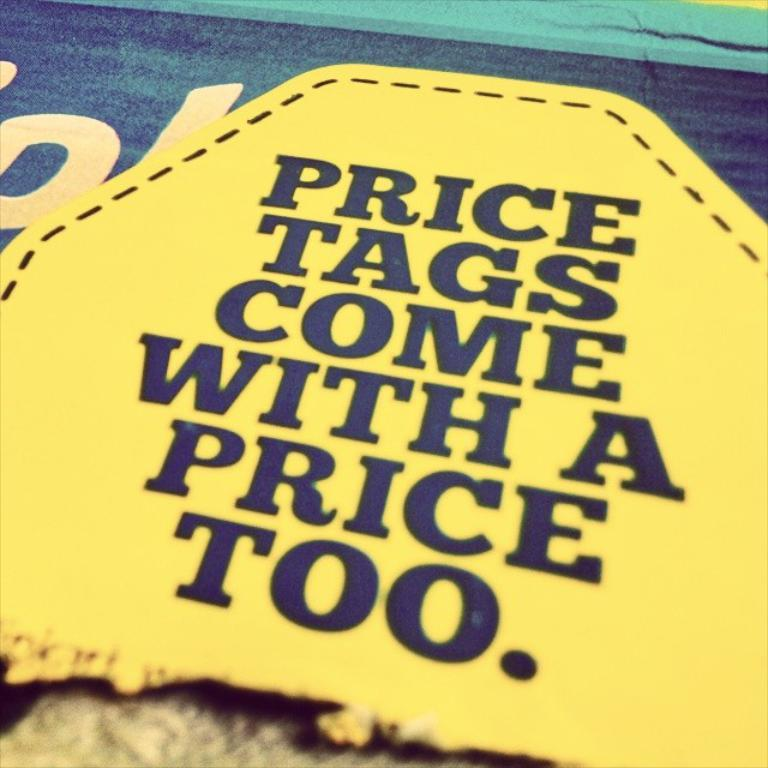<image>
Offer a succinct explanation of the picture presented. A patch that reads, Price tags come with a price too. 